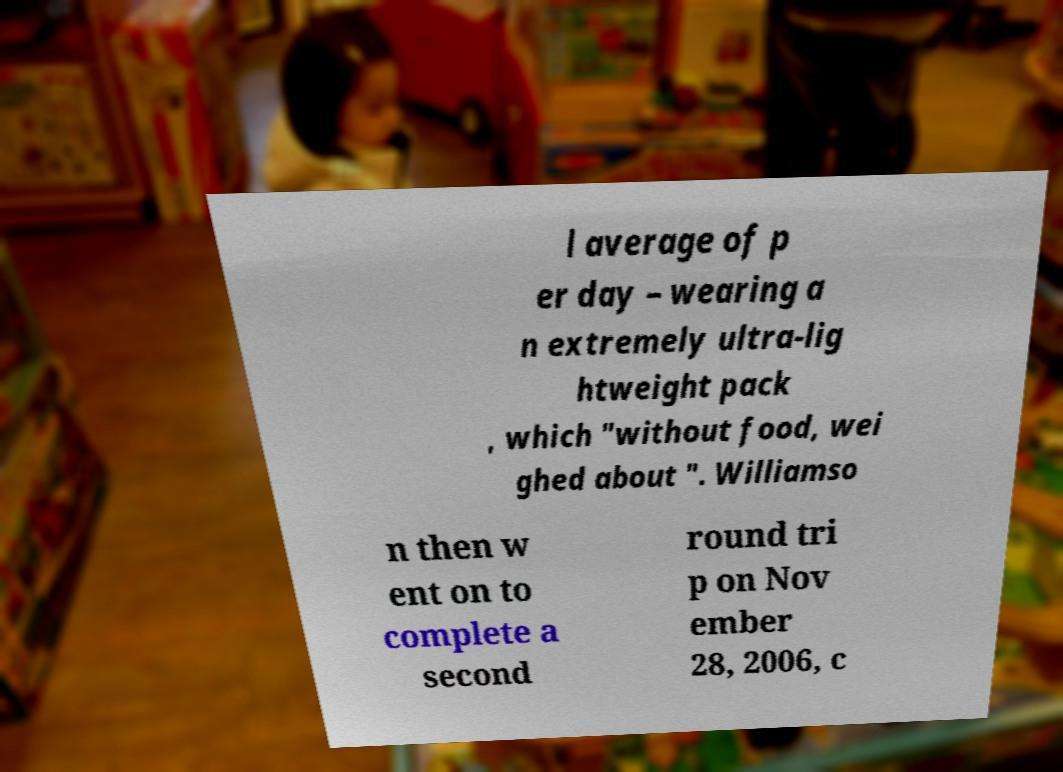Please identify and transcribe the text found in this image. l average of p er day – wearing a n extremely ultra-lig htweight pack , which "without food, wei ghed about ". Williamso n then w ent on to complete a second round tri p on Nov ember 28, 2006, c 